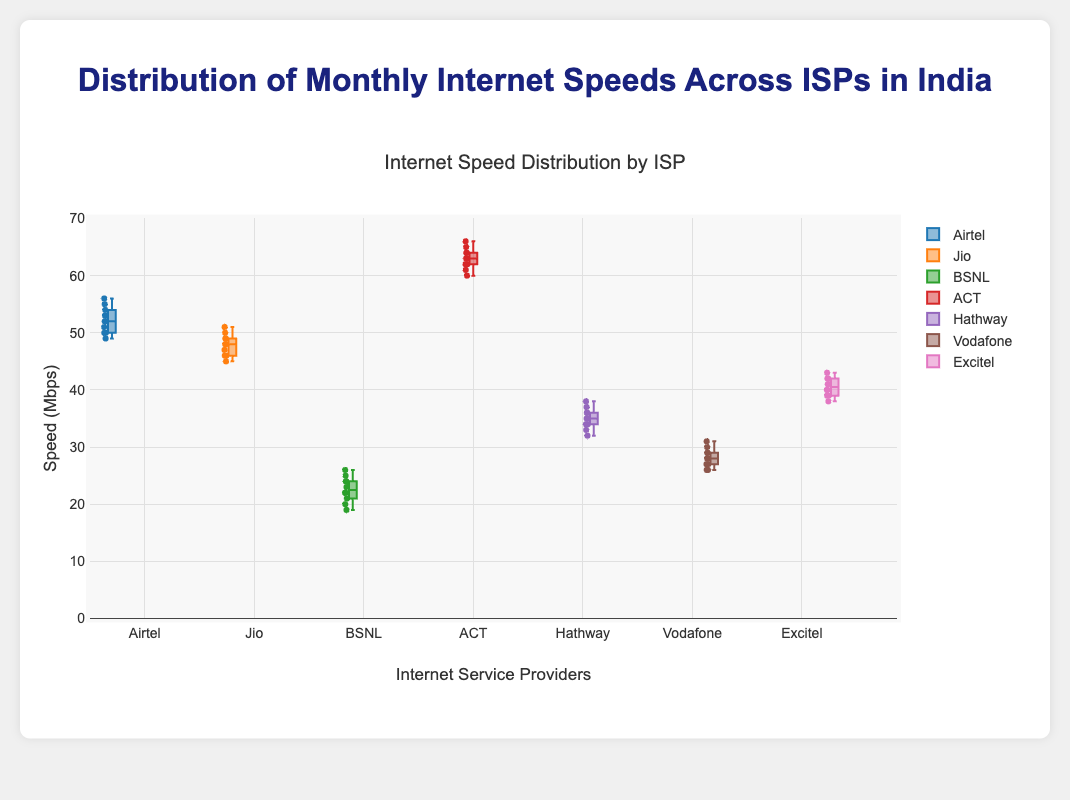What's the title of the figure? The title of the figure is prominently displayed at the top.
Answer: Distribution of Monthly Internet Speeds Across ISPs in India Which ISP has the highest median internet speed? The median speed is indicated by the line inside the box plot. The ISP with the highest median line is "ACT".
Answer: ACT What is the interquartile range (IQR) for Jio? The IQR is the range between the Q1 (25th percentile) and Q3 (75th percentile). For Jio, this lies between the lower and upper edges of the box, approximately 46 and 49.
Answer: 3 Which ISP shows the most variability in internet speeds? The variability can be seen in the length of the whiskers and the spread of points. The ISP "ACT" appears to have the longest whiskers.
Answer: ACT Between Airtel and BSNL, which has the higher maximum speed recorded? The highest point in Airtel is above the highest point in BSNL. Airtel has a maximum around 56 Mbps, whereas BSNL has a maximum around 26 Mbps.
Answer: Airtel What is the median internet speed for Hathway? The median is the line within the box. For Hathway, it aligns around the value of 35 Mbps.
Answer: 35 Mbps Which ISP has the lowest median internet speed? The median speed is indicated by the line inside the box plot, and BSNL has the lowest median speed.
Answer: BSNL How does the speed variability of Vodafone compare with Excitel? The variability can be assessed by the spread of the box and whiskers. Vodafone has a box plot with whiskers extending between roughly 26 and 31, whereas Excitel extends between roughly 38 and 43, indicating higher variability.
Answer: Excitel has higher variability What's the range of speeds for ACT? The range is the difference between the maximum and minimum values. For ACT, it's from about 60 to 66.
Answer: 6 Which ISP has the smallest interquartile range (IQR)? The IQR is the range between the 25th and 75th percentiles. Airtel's box plot appears the most compact, indicating a smaller IQR.
Answer: Airtel 